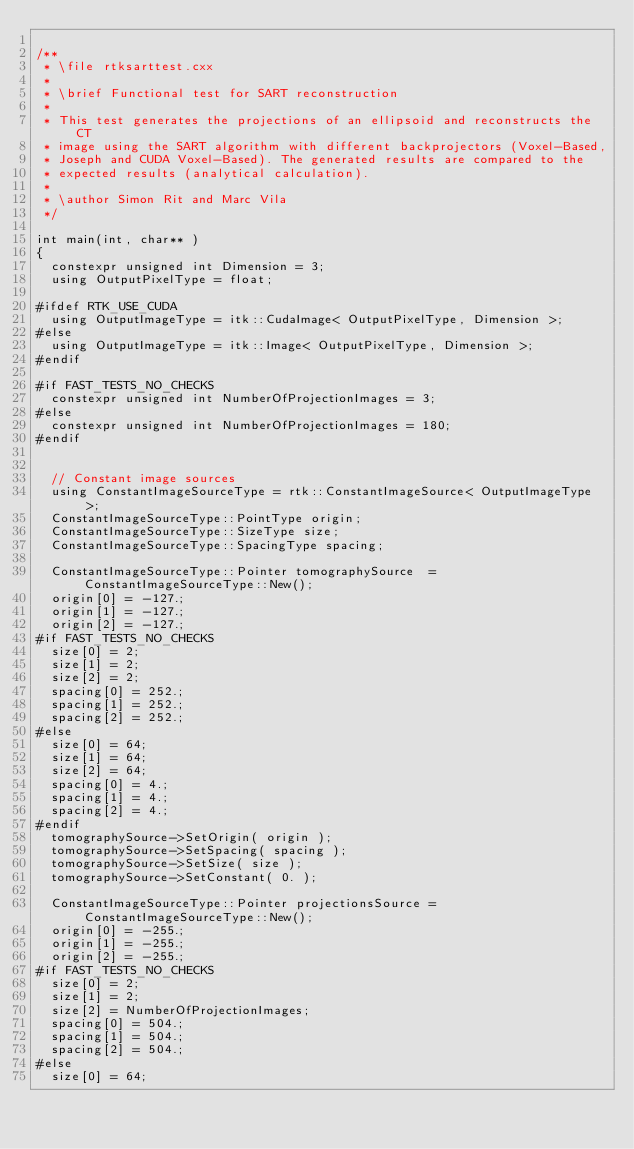<code> <loc_0><loc_0><loc_500><loc_500><_C++_>
/**
 * \file rtksarttest.cxx
 *
 * \brief Functional test for SART reconstruction
 *
 * This test generates the projections of an ellipsoid and reconstructs the CT
 * image using the SART algorithm with different backprojectors (Voxel-Based,
 * Joseph and CUDA Voxel-Based). The generated results are compared to the
 * expected results (analytical calculation).
 *
 * \author Simon Rit and Marc Vila
 */

int main(int, char** )
{
  constexpr unsigned int Dimension = 3;
  using OutputPixelType = float;

#ifdef RTK_USE_CUDA
  using OutputImageType = itk::CudaImage< OutputPixelType, Dimension >;
#else
  using OutputImageType = itk::Image< OutputPixelType, Dimension >;
#endif

#if FAST_TESTS_NO_CHECKS
  constexpr unsigned int NumberOfProjectionImages = 3;
#else
  constexpr unsigned int NumberOfProjectionImages = 180;
#endif


  // Constant image sources
  using ConstantImageSourceType = rtk::ConstantImageSource< OutputImageType >;
  ConstantImageSourceType::PointType origin;
  ConstantImageSourceType::SizeType size;
  ConstantImageSourceType::SpacingType spacing;

  ConstantImageSourceType::Pointer tomographySource  = ConstantImageSourceType::New();
  origin[0] = -127.;
  origin[1] = -127.;
  origin[2] = -127.;
#if FAST_TESTS_NO_CHECKS
  size[0] = 2;
  size[1] = 2;
  size[2] = 2;
  spacing[0] = 252.;
  spacing[1] = 252.;
  spacing[2] = 252.;
#else
  size[0] = 64;
  size[1] = 64;
  size[2] = 64;
  spacing[0] = 4.;
  spacing[1] = 4.;
  spacing[2] = 4.;
#endif
  tomographySource->SetOrigin( origin );
  tomographySource->SetSpacing( spacing );
  tomographySource->SetSize( size );
  tomographySource->SetConstant( 0. );

  ConstantImageSourceType::Pointer projectionsSource = ConstantImageSourceType::New();
  origin[0] = -255.;
  origin[1] = -255.;
  origin[2] = -255.;
#if FAST_TESTS_NO_CHECKS
  size[0] = 2;
  size[1] = 2;
  size[2] = NumberOfProjectionImages;
  spacing[0] = 504.;
  spacing[1] = 504.;
  spacing[2] = 504.;
#else
  size[0] = 64;</code> 